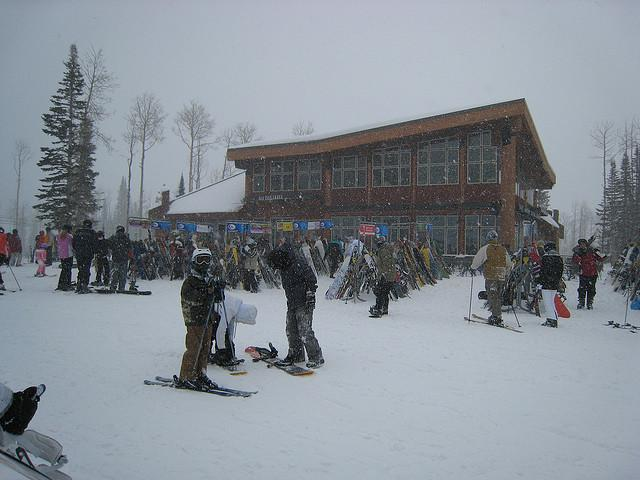Which weather phenomenon is likely to be most frustrating to people seen here at this place? snowstorm 